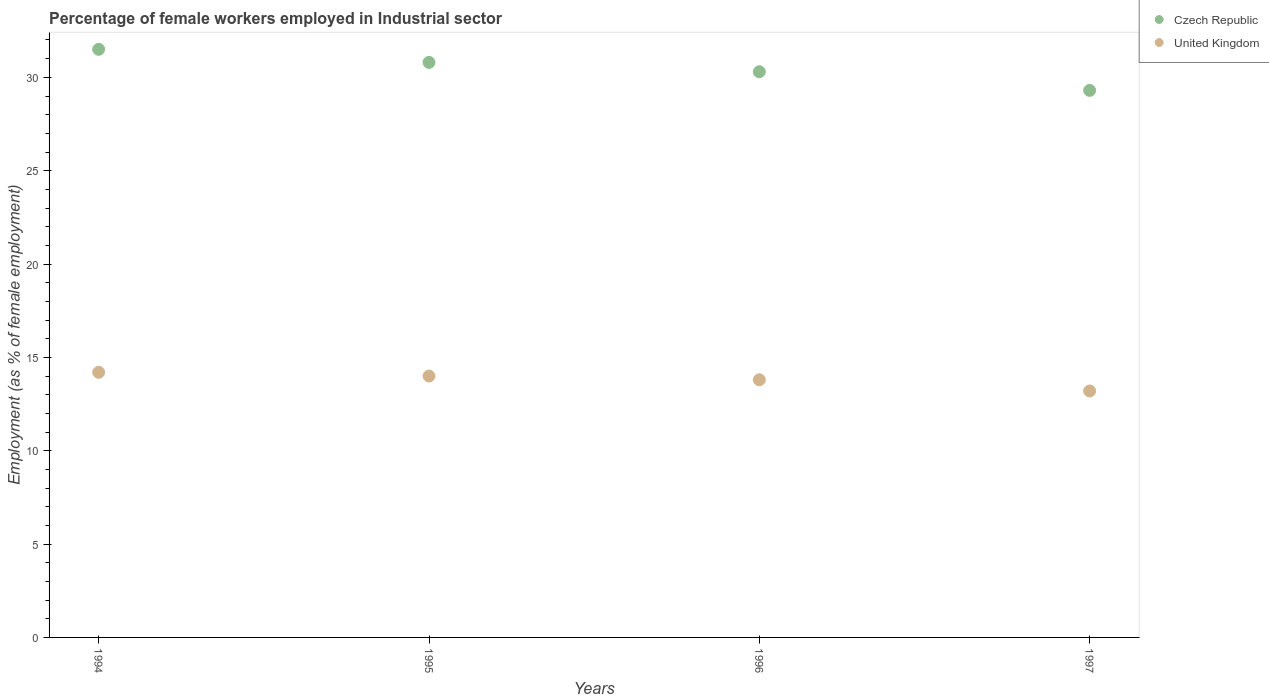Is the number of dotlines equal to the number of legend labels?
Offer a terse response. Yes. What is the percentage of females employed in Industrial sector in Czech Republic in 1996?
Make the answer very short. 30.3. Across all years, what is the maximum percentage of females employed in Industrial sector in United Kingdom?
Your response must be concise. 14.2. Across all years, what is the minimum percentage of females employed in Industrial sector in Czech Republic?
Your response must be concise. 29.3. In which year was the percentage of females employed in Industrial sector in Czech Republic maximum?
Keep it short and to the point. 1994. In which year was the percentage of females employed in Industrial sector in United Kingdom minimum?
Provide a short and direct response. 1997. What is the total percentage of females employed in Industrial sector in United Kingdom in the graph?
Give a very brief answer. 55.2. What is the difference between the percentage of females employed in Industrial sector in United Kingdom in 1995 and that in 1996?
Ensure brevity in your answer.  0.2. What is the average percentage of females employed in Industrial sector in United Kingdom per year?
Offer a terse response. 13.8. In the year 1994, what is the difference between the percentage of females employed in Industrial sector in United Kingdom and percentage of females employed in Industrial sector in Czech Republic?
Offer a terse response. -17.3. In how many years, is the percentage of females employed in Industrial sector in Czech Republic greater than 21 %?
Offer a very short reply. 4. What is the ratio of the percentage of females employed in Industrial sector in Czech Republic in 1994 to that in 1995?
Keep it short and to the point. 1.02. Is the percentage of females employed in Industrial sector in United Kingdom in 1995 less than that in 1996?
Make the answer very short. No. Is the difference between the percentage of females employed in Industrial sector in United Kingdom in 1994 and 1997 greater than the difference between the percentage of females employed in Industrial sector in Czech Republic in 1994 and 1997?
Ensure brevity in your answer.  No. What is the difference between the highest and the second highest percentage of females employed in Industrial sector in United Kingdom?
Keep it short and to the point. 0.2. What is the difference between the highest and the lowest percentage of females employed in Industrial sector in Czech Republic?
Your answer should be compact. 2.2. In how many years, is the percentage of females employed in Industrial sector in Czech Republic greater than the average percentage of females employed in Industrial sector in Czech Republic taken over all years?
Make the answer very short. 2. Is the sum of the percentage of females employed in Industrial sector in United Kingdom in 1994 and 1995 greater than the maximum percentage of females employed in Industrial sector in Czech Republic across all years?
Provide a succinct answer. No. Is the percentage of females employed in Industrial sector in United Kingdom strictly greater than the percentage of females employed in Industrial sector in Czech Republic over the years?
Your response must be concise. No. Is the percentage of females employed in Industrial sector in United Kingdom strictly less than the percentage of females employed in Industrial sector in Czech Republic over the years?
Offer a very short reply. Yes. How many years are there in the graph?
Provide a succinct answer. 4. What is the difference between two consecutive major ticks on the Y-axis?
Offer a very short reply. 5. What is the title of the graph?
Make the answer very short. Percentage of female workers employed in Industrial sector. Does "Vanuatu" appear as one of the legend labels in the graph?
Offer a very short reply. No. What is the label or title of the X-axis?
Your response must be concise. Years. What is the label or title of the Y-axis?
Your answer should be compact. Employment (as % of female employment). What is the Employment (as % of female employment) of Czech Republic in 1994?
Keep it short and to the point. 31.5. What is the Employment (as % of female employment) of United Kingdom in 1994?
Offer a very short reply. 14.2. What is the Employment (as % of female employment) in Czech Republic in 1995?
Offer a terse response. 30.8. What is the Employment (as % of female employment) in United Kingdom in 1995?
Your response must be concise. 14. What is the Employment (as % of female employment) of Czech Republic in 1996?
Ensure brevity in your answer.  30.3. What is the Employment (as % of female employment) of United Kingdom in 1996?
Provide a short and direct response. 13.8. What is the Employment (as % of female employment) of Czech Republic in 1997?
Ensure brevity in your answer.  29.3. What is the Employment (as % of female employment) of United Kingdom in 1997?
Offer a very short reply. 13.2. Across all years, what is the maximum Employment (as % of female employment) of Czech Republic?
Your answer should be compact. 31.5. Across all years, what is the maximum Employment (as % of female employment) of United Kingdom?
Offer a very short reply. 14.2. Across all years, what is the minimum Employment (as % of female employment) of Czech Republic?
Your response must be concise. 29.3. Across all years, what is the minimum Employment (as % of female employment) of United Kingdom?
Your answer should be very brief. 13.2. What is the total Employment (as % of female employment) in Czech Republic in the graph?
Your response must be concise. 121.9. What is the total Employment (as % of female employment) of United Kingdom in the graph?
Your answer should be very brief. 55.2. What is the difference between the Employment (as % of female employment) of United Kingdom in 1994 and that in 1995?
Your answer should be very brief. 0.2. What is the difference between the Employment (as % of female employment) in Czech Republic in 1994 and that in 1996?
Offer a terse response. 1.2. What is the difference between the Employment (as % of female employment) of Czech Republic in 1994 and that in 1997?
Your answer should be very brief. 2.2. What is the difference between the Employment (as % of female employment) of United Kingdom in 1994 and that in 1997?
Offer a very short reply. 1. What is the difference between the Employment (as % of female employment) in Czech Republic in 1995 and that in 1997?
Ensure brevity in your answer.  1.5. What is the difference between the Employment (as % of female employment) in United Kingdom in 1995 and that in 1997?
Ensure brevity in your answer.  0.8. What is the difference between the Employment (as % of female employment) of Czech Republic in 1994 and the Employment (as % of female employment) of United Kingdom in 1995?
Keep it short and to the point. 17.5. What is the difference between the Employment (as % of female employment) in Czech Republic in 1994 and the Employment (as % of female employment) in United Kingdom in 1996?
Your answer should be very brief. 17.7. What is the difference between the Employment (as % of female employment) of Czech Republic in 1994 and the Employment (as % of female employment) of United Kingdom in 1997?
Keep it short and to the point. 18.3. What is the difference between the Employment (as % of female employment) in Czech Republic in 1996 and the Employment (as % of female employment) in United Kingdom in 1997?
Provide a succinct answer. 17.1. What is the average Employment (as % of female employment) of Czech Republic per year?
Give a very brief answer. 30.48. What is the average Employment (as % of female employment) in United Kingdom per year?
Your answer should be compact. 13.8. In the year 1995, what is the difference between the Employment (as % of female employment) in Czech Republic and Employment (as % of female employment) in United Kingdom?
Give a very brief answer. 16.8. In the year 1997, what is the difference between the Employment (as % of female employment) in Czech Republic and Employment (as % of female employment) in United Kingdom?
Offer a terse response. 16.1. What is the ratio of the Employment (as % of female employment) of Czech Republic in 1994 to that in 1995?
Make the answer very short. 1.02. What is the ratio of the Employment (as % of female employment) in United Kingdom in 1994 to that in 1995?
Ensure brevity in your answer.  1.01. What is the ratio of the Employment (as % of female employment) of Czech Republic in 1994 to that in 1996?
Provide a short and direct response. 1.04. What is the ratio of the Employment (as % of female employment) in United Kingdom in 1994 to that in 1996?
Offer a very short reply. 1.03. What is the ratio of the Employment (as % of female employment) in Czech Republic in 1994 to that in 1997?
Keep it short and to the point. 1.08. What is the ratio of the Employment (as % of female employment) in United Kingdom in 1994 to that in 1997?
Your answer should be compact. 1.08. What is the ratio of the Employment (as % of female employment) of Czech Republic in 1995 to that in 1996?
Keep it short and to the point. 1.02. What is the ratio of the Employment (as % of female employment) in United Kingdom in 1995 to that in 1996?
Your answer should be very brief. 1.01. What is the ratio of the Employment (as % of female employment) of Czech Republic in 1995 to that in 1997?
Ensure brevity in your answer.  1.05. What is the ratio of the Employment (as % of female employment) in United Kingdom in 1995 to that in 1997?
Your answer should be very brief. 1.06. What is the ratio of the Employment (as % of female employment) of Czech Republic in 1996 to that in 1997?
Provide a short and direct response. 1.03. What is the ratio of the Employment (as % of female employment) of United Kingdom in 1996 to that in 1997?
Keep it short and to the point. 1.05. What is the difference between the highest and the second highest Employment (as % of female employment) in United Kingdom?
Ensure brevity in your answer.  0.2. 